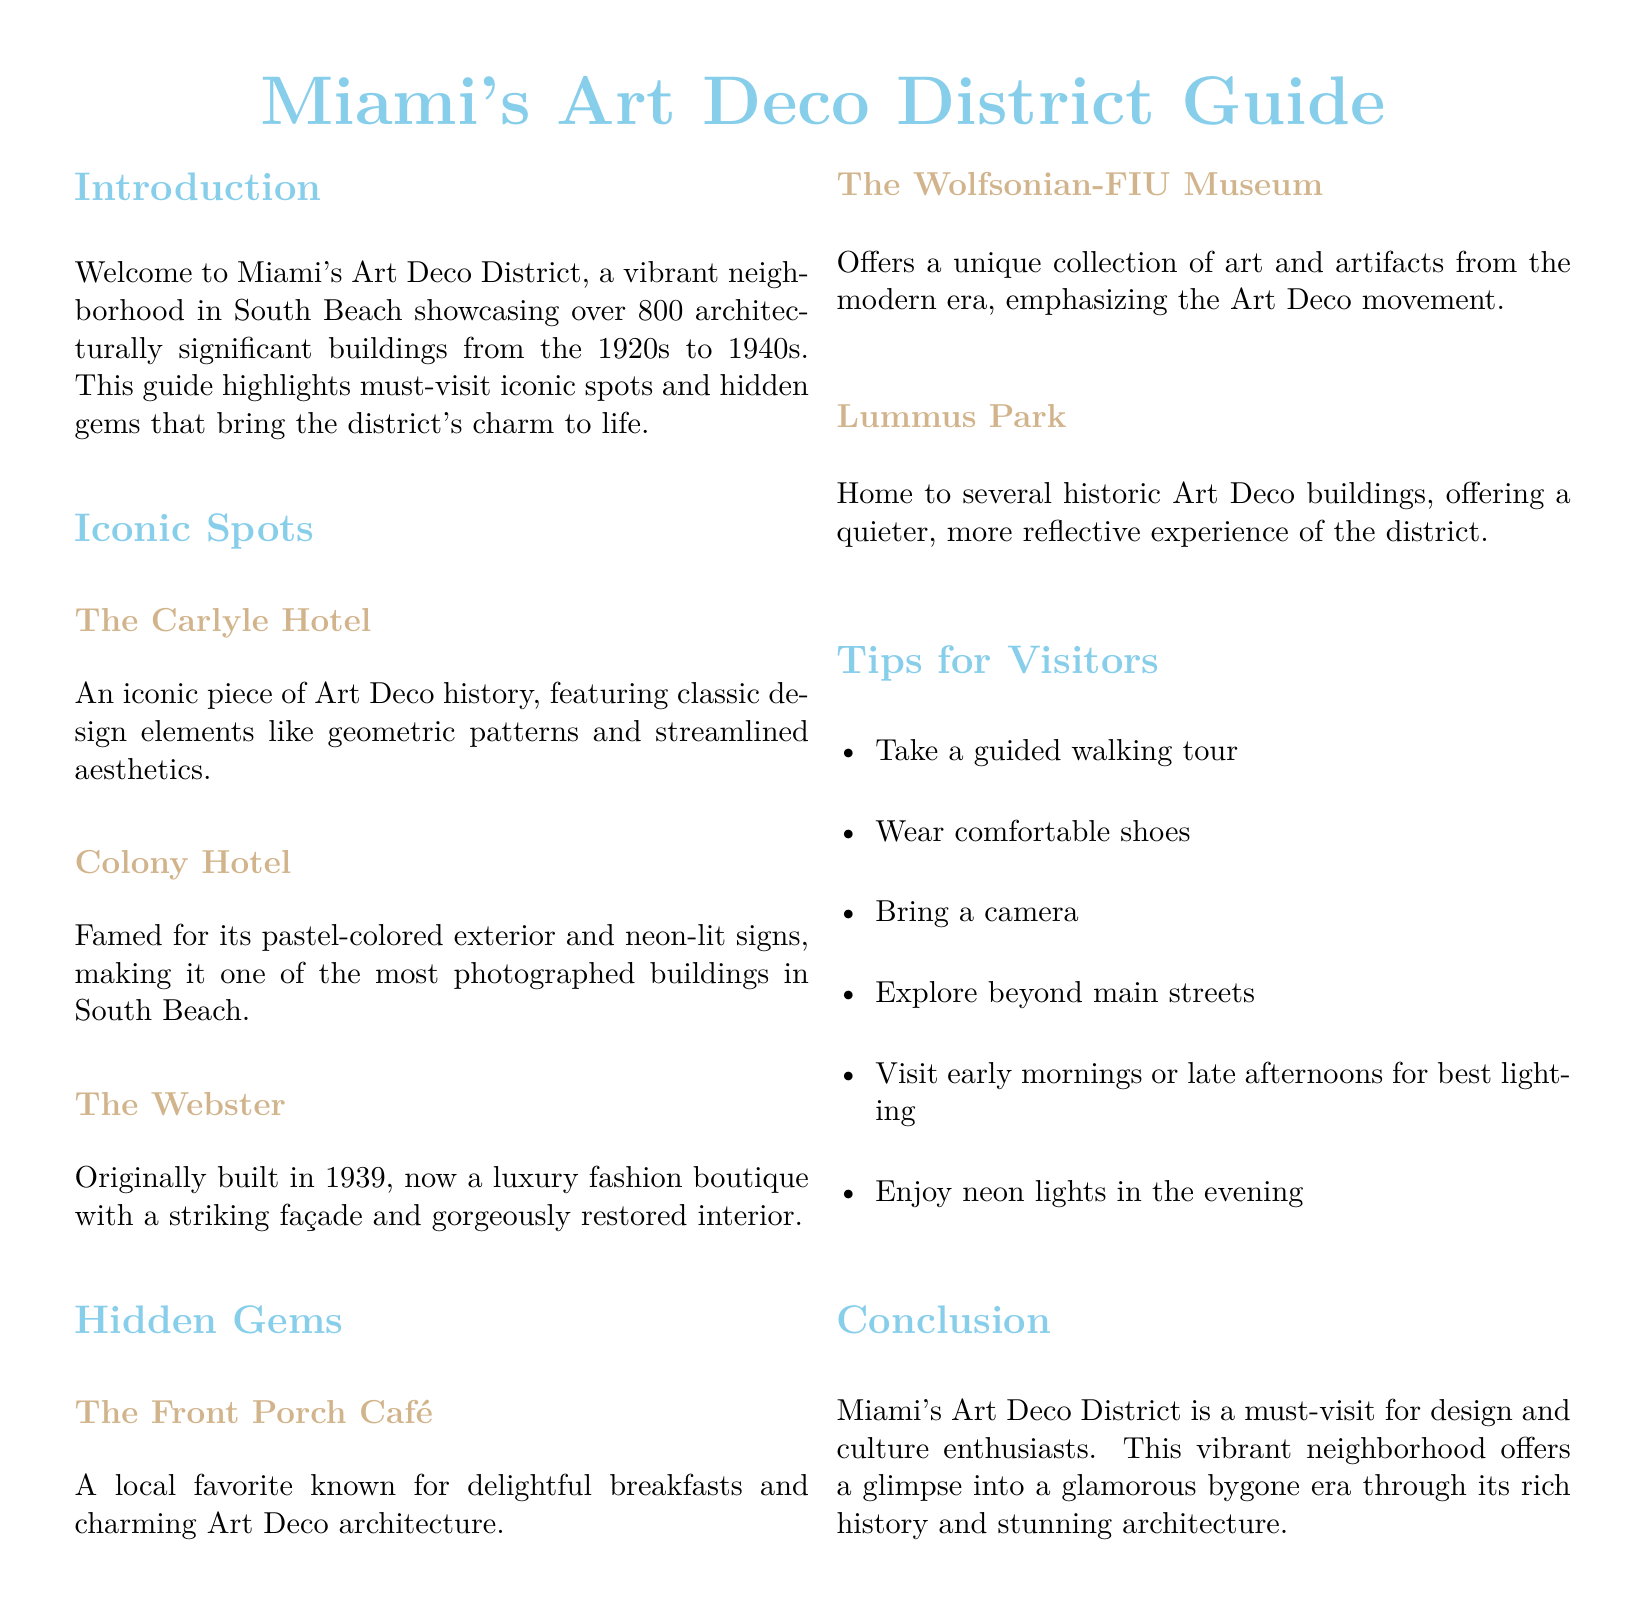What is the total number of architecturally significant buildings in Miami's Art Deco District? The document states that there are over 800 buildings in the Art Deco District.
Answer: over 800 What is the name of the luxury fashion boutique originally built in 1939? The document mentions The Webster as the luxury fashion boutique.
Answer: The Webster What type of food is the Front Porch Café known for? The document describes the Front Porch Café as known for delightful breakfasts.
Answer: breakfasts What is a recommended time to visit for the best lighting? According to the tips for visitors, early mornings or late afternoons provide the best lighting.
Answer: early mornings or late afternoons Which museum offers a unique collection of art and artifacts from the modern era? The Wolfsonian-FIU Museum is indicated in the document as offering a unique collection.
Answer: The Wolfsonian-FIU Museum What design elements are featured in the Carlyle Hotel? The document highlights classic design elements like geometric patterns and streamlined aesthetics for the Carlyle Hotel.
Answer: geometric patterns and streamlined aesthetics What type of experience does Lummus Park offer? Lummus Park provides a quieter, more reflective experience according to the document.
Answer: quieter, more reflective experience What is a notable feature of the Colony Hotel? The Colony Hotel is famed for its pastel-colored exterior and neon-lit signs.
Answer: pastel-colored exterior and neon-lit signs 